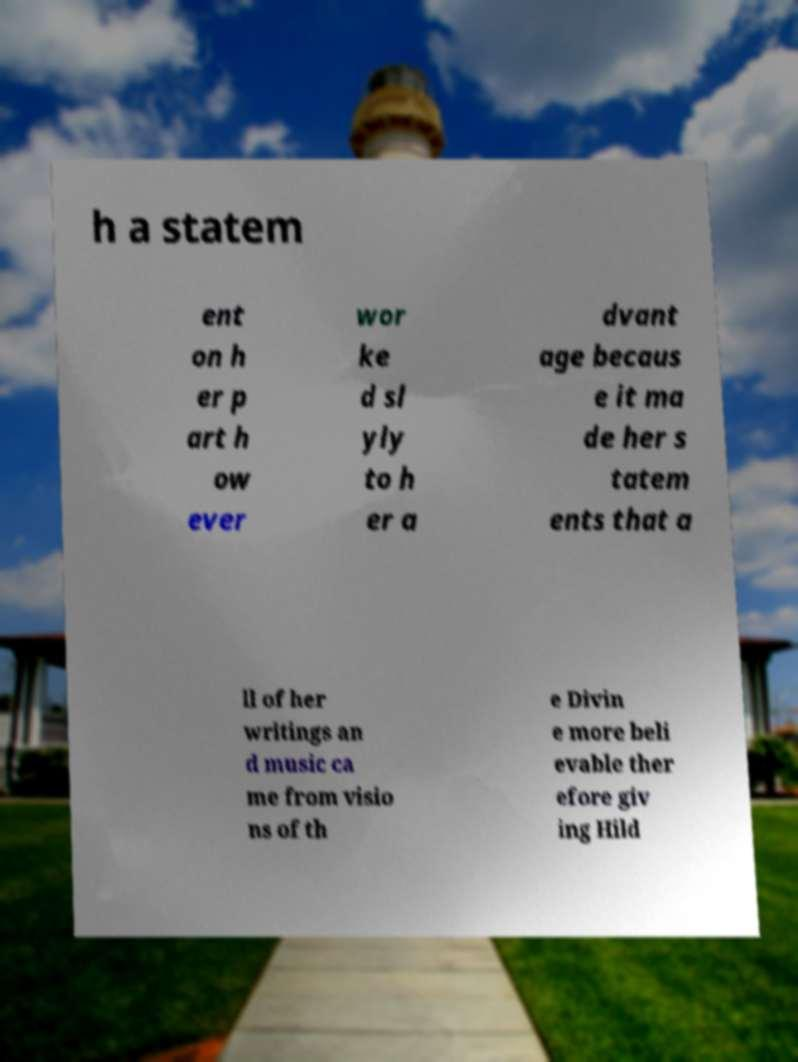There's text embedded in this image that I need extracted. Can you transcribe it verbatim? h a statem ent on h er p art h ow ever wor ke d sl yly to h er a dvant age becaus e it ma de her s tatem ents that a ll of her writings an d music ca me from visio ns of th e Divin e more beli evable ther efore giv ing Hild 